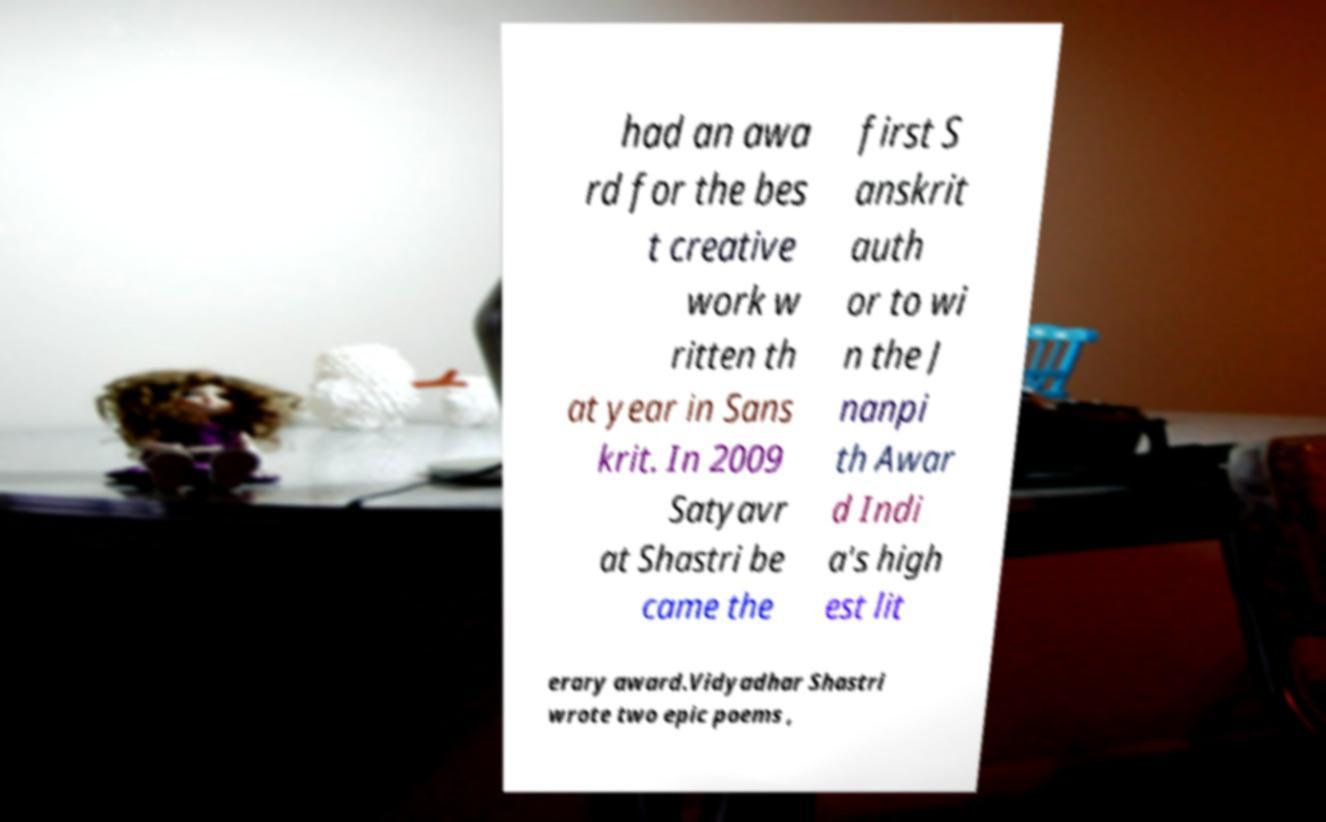For documentation purposes, I need the text within this image transcribed. Could you provide that? had an awa rd for the bes t creative work w ritten th at year in Sans krit. In 2009 Satyavr at Shastri be came the first S anskrit auth or to wi n the J nanpi th Awar d Indi a's high est lit erary award.Vidyadhar Shastri wrote two epic poems , 